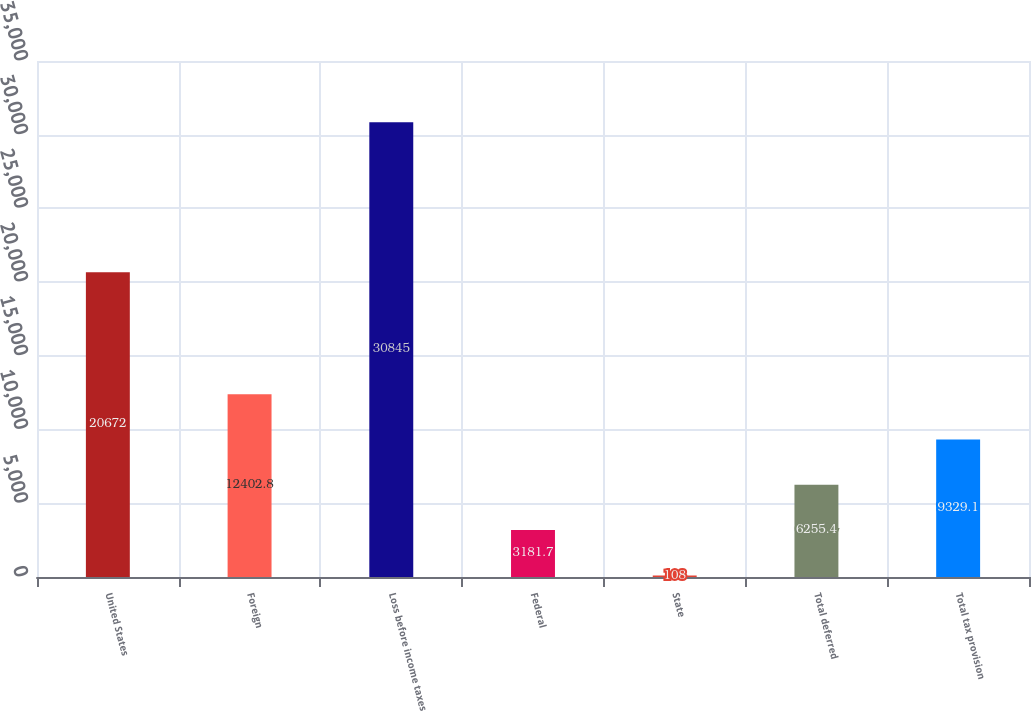Convert chart. <chart><loc_0><loc_0><loc_500><loc_500><bar_chart><fcel>United States<fcel>Foreign<fcel>Loss before income taxes<fcel>Federal<fcel>State<fcel>Total deferred<fcel>Total tax provision<nl><fcel>20672<fcel>12402.8<fcel>30845<fcel>3181.7<fcel>108<fcel>6255.4<fcel>9329.1<nl></chart> 